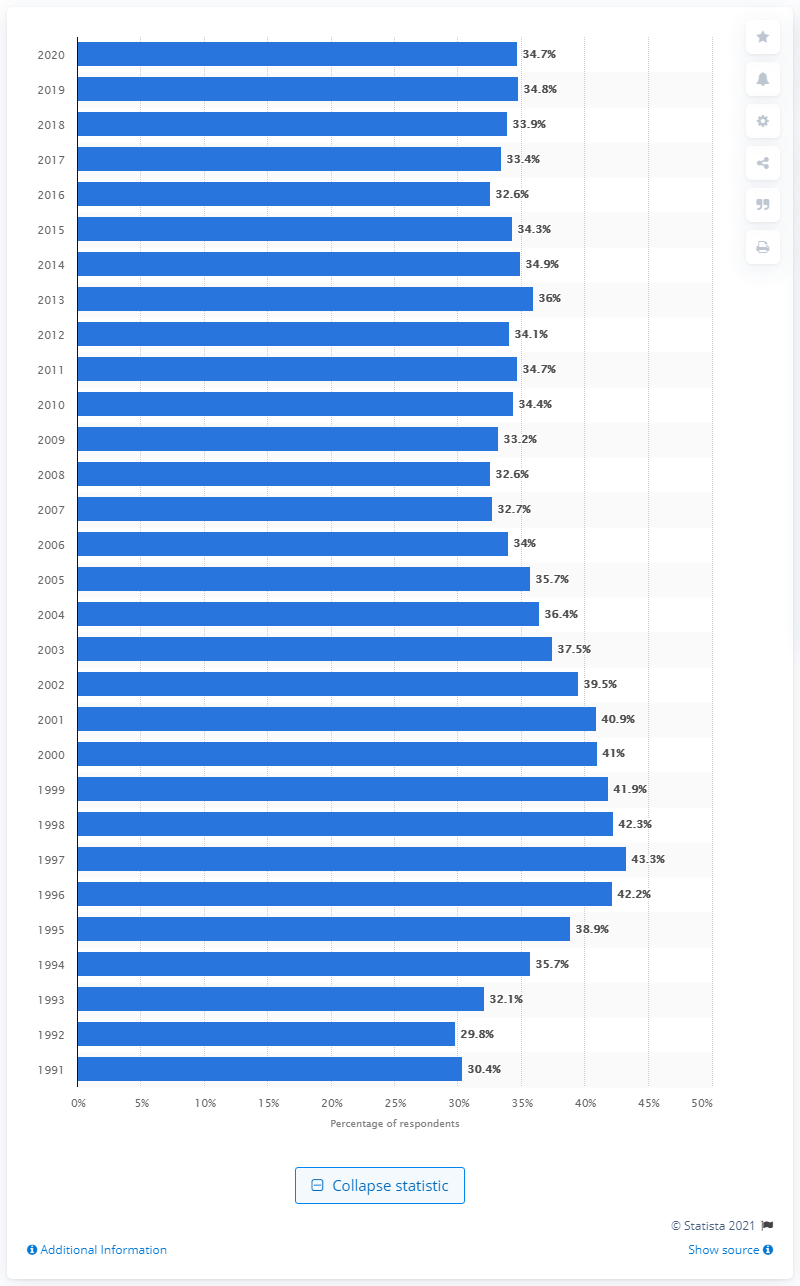Mention a couple of crucial points in this snapshot. According to the data collected in 2020, 34.7% of all respondents in grades 8, 10, and 12 reported having used any illicit drug at least once in their lifetime. 